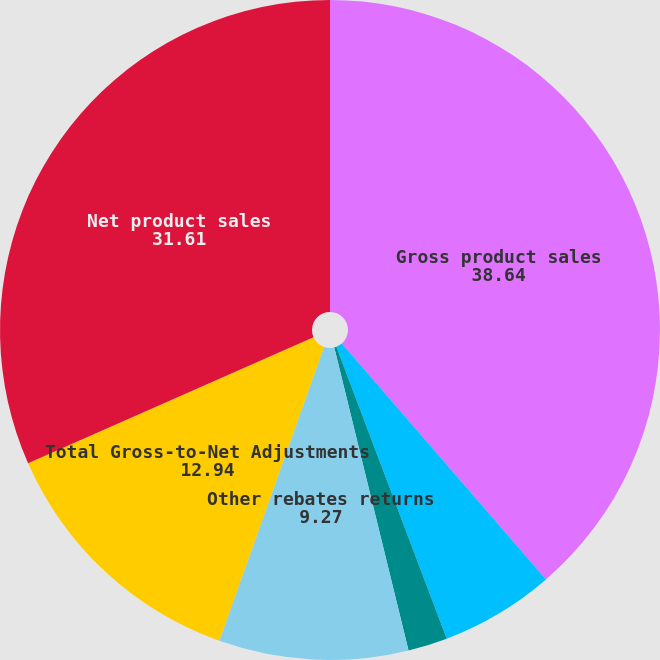Convert chart. <chart><loc_0><loc_0><loc_500><loc_500><pie_chart><fcel>Gross product sales<fcel>Charge-backs and cash<fcel>Medicaid and Medicare rebates<fcel>Other rebates returns<fcel>Total Gross-to-Net Adjustments<fcel>Net product sales<nl><fcel>38.64%<fcel>5.6%<fcel>1.93%<fcel>9.27%<fcel>12.94%<fcel>31.61%<nl></chart> 